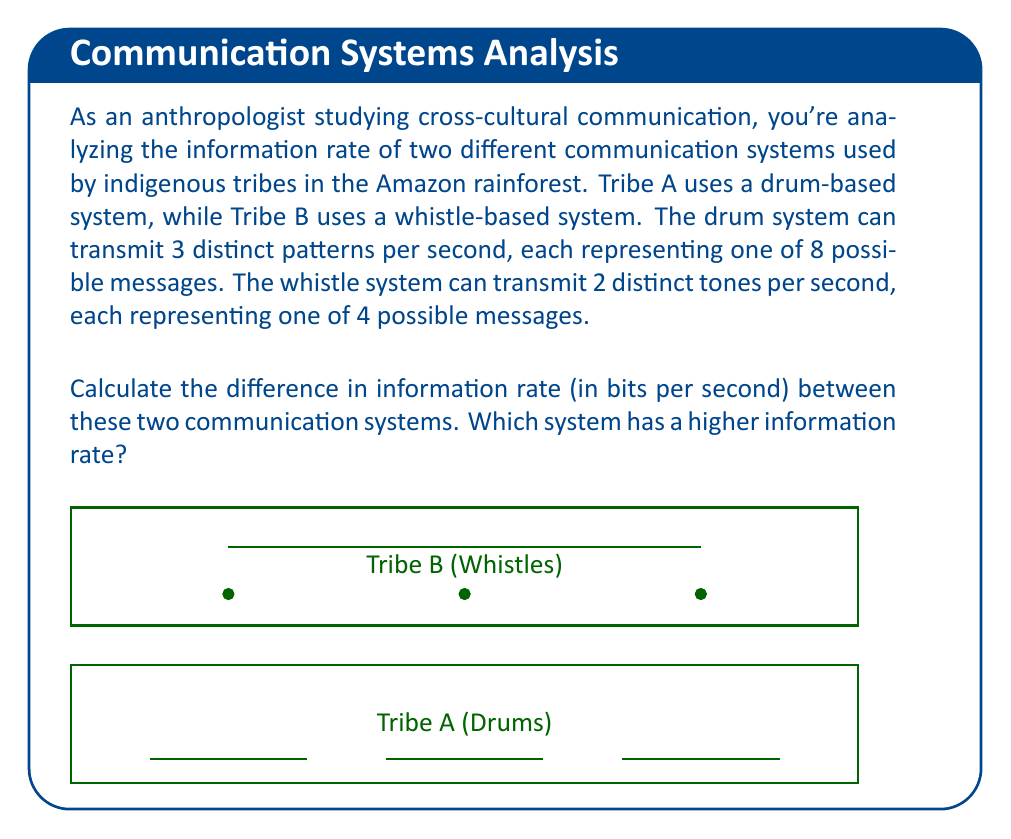Can you solve this math problem? Let's approach this step-by-step:

1) First, we need to calculate the information content of each message in both systems.

   For Tribe A (drums):
   - 8 possible messages
   - Information content = $\log_2(8) = 3$ bits per message

   For Tribe B (whistles):
   - 4 possible messages
   - Information content = $\log_2(4) = 2$ bits per message

2) Now, let's calculate the information rate for each system:

   Tribe A (drums):
   - 3 patterns per second
   - Information rate = $3 \text{ patterns/s} \times 3 \text{ bits/pattern} = 9 \text{ bits/s}$

   Tribe B (whistles):
   - 2 tones per second
   - Information rate = $2 \text{ tones/s} \times 2 \text{ bits/tone} = 4 \text{ bits/s}$

3) To find the difference in information rate:
   $9 \text{ bits/s} - 4 \text{ bits/s} = 5 \text{ bits/s}$

4) Comparing the rates:
   Tribe A (drums): 9 bits/s
   Tribe B (whistles): 4 bits/s

   The drum-based system (Tribe A) has a higher information rate.
Answer: 5 bits/s; Drum system 